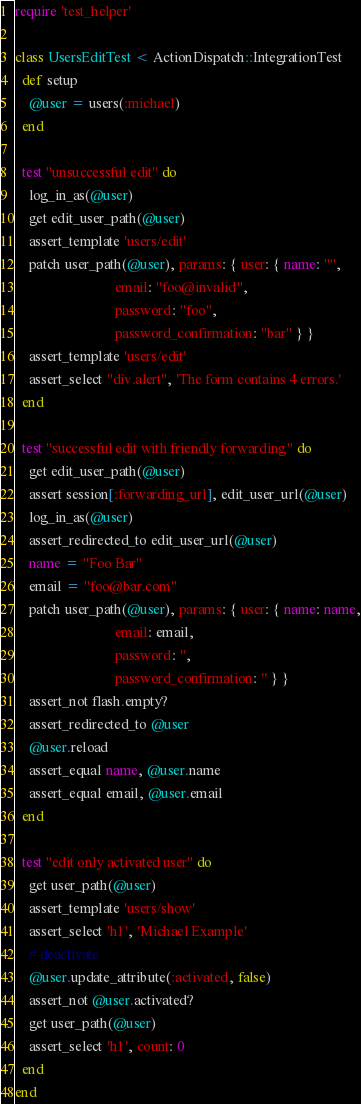<code> <loc_0><loc_0><loc_500><loc_500><_Ruby_>require 'test_helper'

class UsersEditTest < ActionDispatch::IntegrationTest
  def setup
    @user = users(:michael)
  end

  test "unsuccessful edit" do
    log_in_as(@user)
    get edit_user_path(@user)
    assert_template 'users/edit'
    patch user_path(@user), params: { user: { name: "",
                            email: "foo@invalid",
                            password: "foo",
                            password_confirmation: "bar" } }
    assert_template 'users/edit'
    assert_select "div.alert", 'The form contains 4 errors.'
  end

  test "successful edit with friendly forwarding" do
    get edit_user_path(@user)
    assert session[:forwarding_url], edit_user_url(@user)
    log_in_as(@user)
    assert_redirected_to edit_user_url(@user)
    name = "Foo Bar"
    email = "foo@bar.com"
    patch user_path(@user), params: { user: { name: name,
                            email: email,
                            password: '',
                            password_confirmation: '' } }
    assert_not flash.empty?
    assert_redirected_to @user
    @user.reload
    assert_equal name, @user.name
    assert_equal email, @user.email
  end

  test "edit only activated user" do
    get user_path(@user)
    assert_template 'users/show'
    assert_select 'h1', 'Michael Example'
    # deactivate
    @user.update_attribute(:activated, false)
    assert_not @user.activated?
    get user_path(@user)
    assert_select 'h1', count: 0
  end
end
</code> 